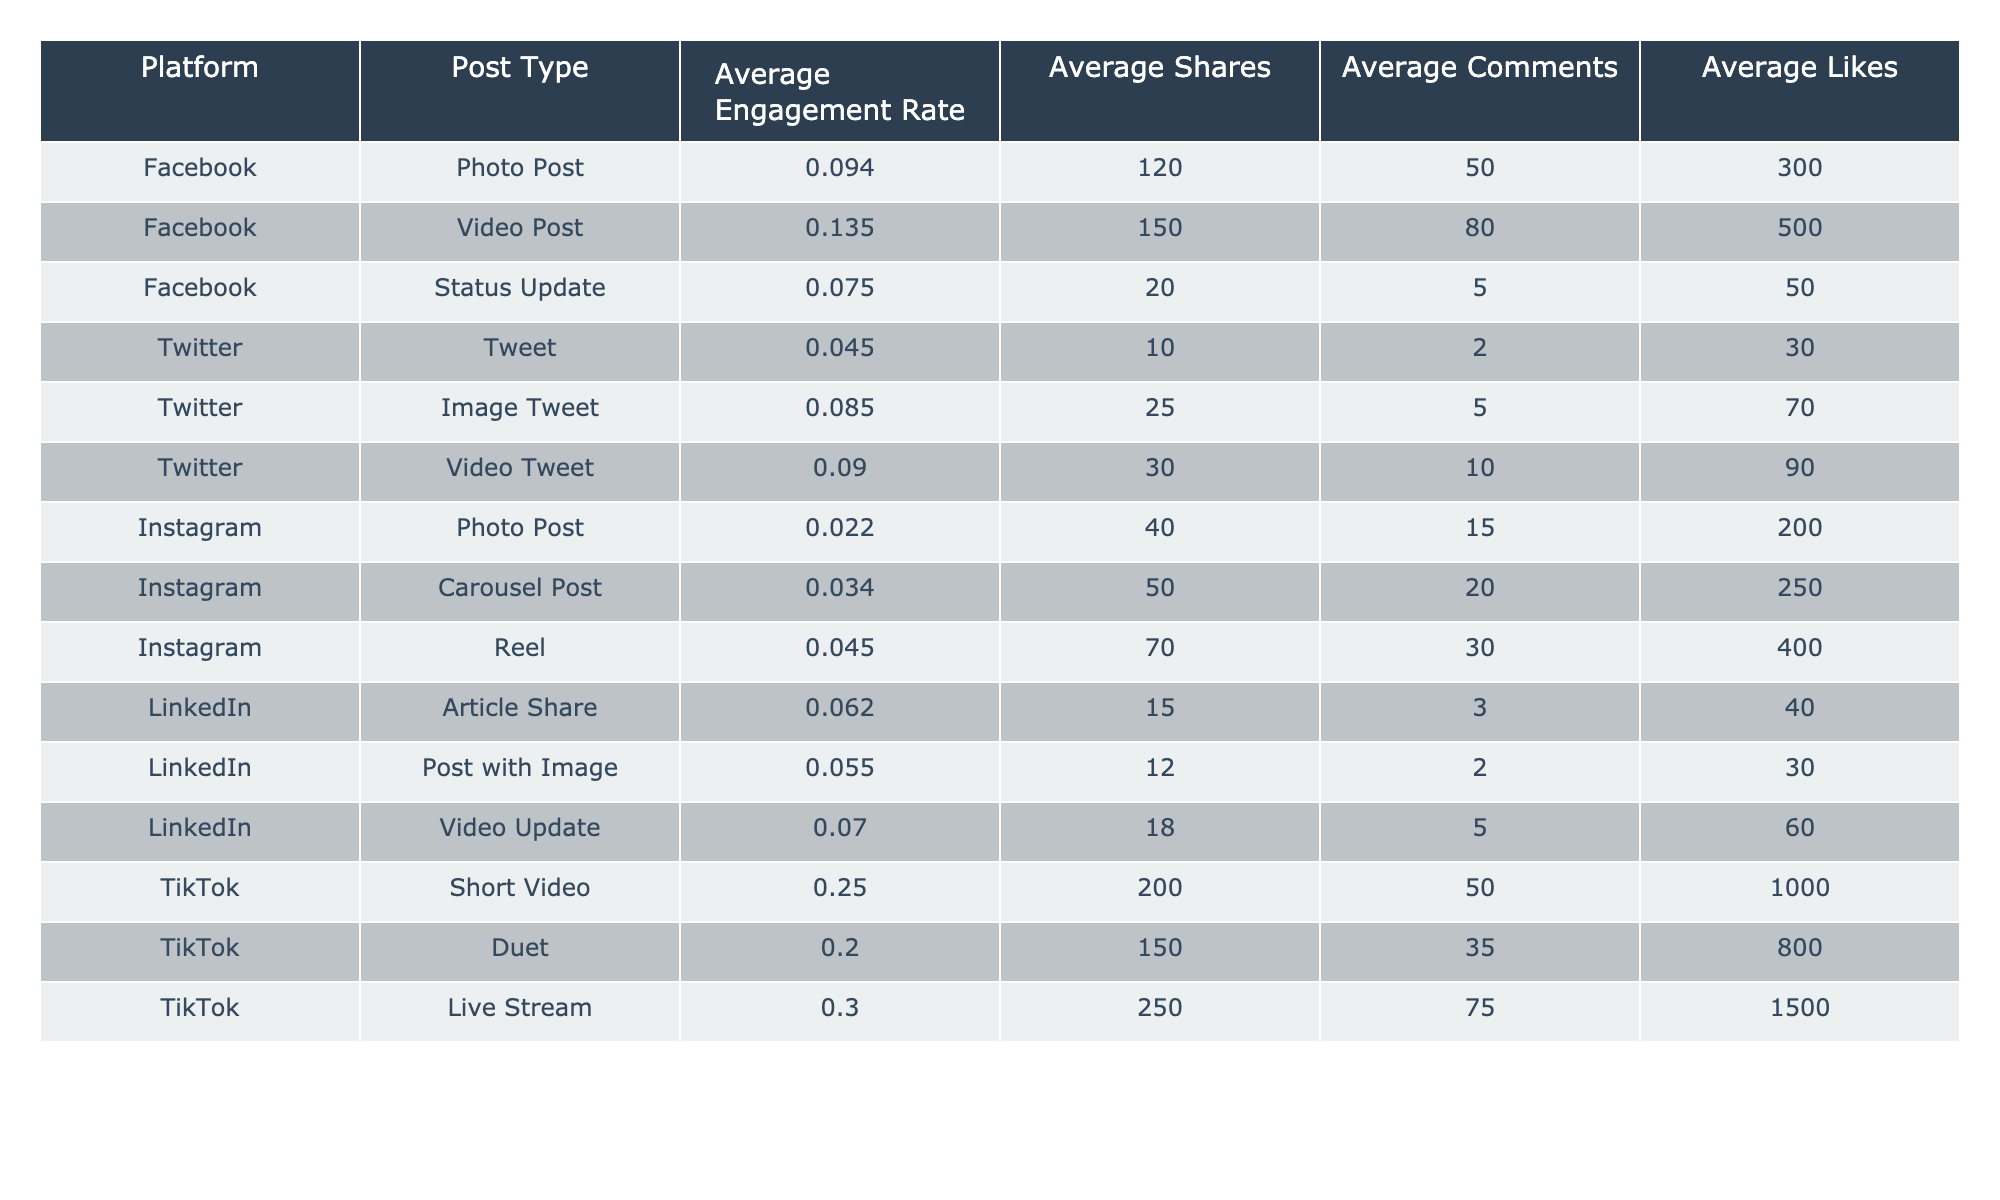What is the average engagement rate for TikTok's Live Stream post type? The table indicates that the average engagement rate for TikTok's Live Stream is 0.300.
Answer: 0.300 Which post type has the highest average likes on Facebook? From the table, the Video Post on Facebook has the highest average likes at 500.
Answer: 500 Is the average engagement rate for a video post on Instagram greater than that of a photo post? The table shows that the average engagement rate for the Reel (0.045) is greater than that for the Photo Post (0.022), confirming this statement.
Answer: Yes What is the combined total of average likes for all post types on LinkedIn? Adding the average likes of Article Share (40), Post with Image (30), and Video Update (60) gives a total of 130 likes for LinkedIn.
Answer: 130 Which platform has the post type with the lowest average engagement rate? The Instagram Photo Post has the lowest engagement rate at 0.022 among all listed post types.
Answer: Instagram Photo Post What is the difference in average shares between TikTok's Short Video and Facebook's Video Post? The average shares for TikTok's Short Video is 200 and Facebook's Video Post is 150, so the difference is 200 - 150 = 50.
Answer: 50 Are the average comments for Twitter's Image Tweet and Facebook's Status Update the same? The average comments are not the same; Twitter's Image Tweet has 5 comments, while Facebook's Status Update has 5 comments.
Answer: No Which post type has the highest average engagement rate and what is that rate? The table reveals that TikTok's Live Stream has the highest engagement rate at 0.300.
Answer: TikTok Live Stream, 0.300 What is the average number of shares across all post types on Facebook? The average shares for Facebook can be calculated as (120 + 150 + 20) / 3 = 96.67.
Answer: 96.67 Are Instagram's Carousel Posts more likely to receive likes than its Photo Posts? The average likes for the Carousel Post (250) is greater than that for the Photo Post (200), confirming the statement.
Answer: Yes 